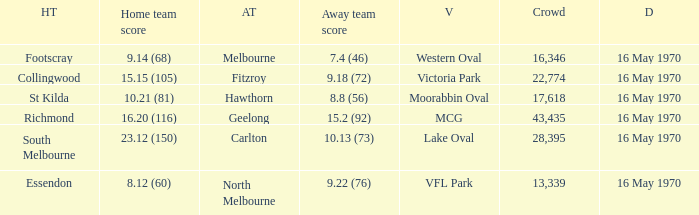Help me parse the entirety of this table. {'header': ['HT', 'Home team score', 'AT', 'Away team score', 'V', 'Crowd', 'D'], 'rows': [['Footscray', '9.14 (68)', 'Melbourne', '7.4 (46)', 'Western Oval', '16,346', '16 May 1970'], ['Collingwood', '15.15 (105)', 'Fitzroy', '9.18 (72)', 'Victoria Park', '22,774', '16 May 1970'], ['St Kilda', '10.21 (81)', 'Hawthorn', '8.8 (56)', 'Moorabbin Oval', '17,618', '16 May 1970'], ['Richmond', '16.20 (116)', 'Geelong', '15.2 (92)', 'MCG', '43,435', '16 May 1970'], ['South Melbourne', '23.12 (150)', 'Carlton', '10.13 (73)', 'Lake Oval', '28,395', '16 May 1970'], ['Essendon', '8.12 (60)', 'North Melbourne', '9.22 (76)', 'VFL Park', '13,339', '16 May 1970']]} What's the venue for the home team that scored 9.14 (68)? Western Oval. 